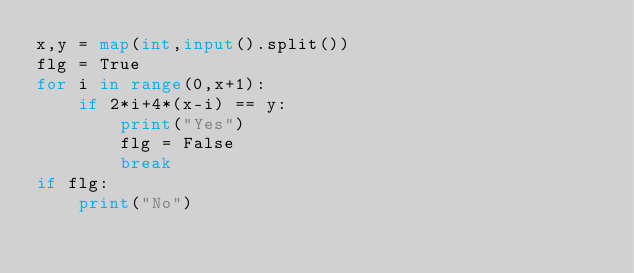<code> <loc_0><loc_0><loc_500><loc_500><_Python_>x,y = map(int,input().split())
flg = True
for i in range(0,x+1):
    if 2*i+4*(x-i) == y:
        print("Yes")
        flg = False
        break
if flg:
    print("No")
</code> 